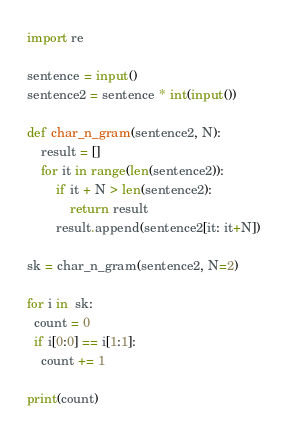Convert code to text. <code><loc_0><loc_0><loc_500><loc_500><_Python_>import re

sentence = input()
sentence2 = sentence * int(input())

def char_n_gram(sentence2, N):
    result = []
    for it in range(len(sentence2)):
        if it + N > len(sentence2):
            return result
        result.append(sentence2[it: it+N])

sk = char_n_gram(sentence2, N=2)

for i in  sk:
  count = 0
  if i[0:0] == i[1:1]:
    count += 1

print(count)</code> 